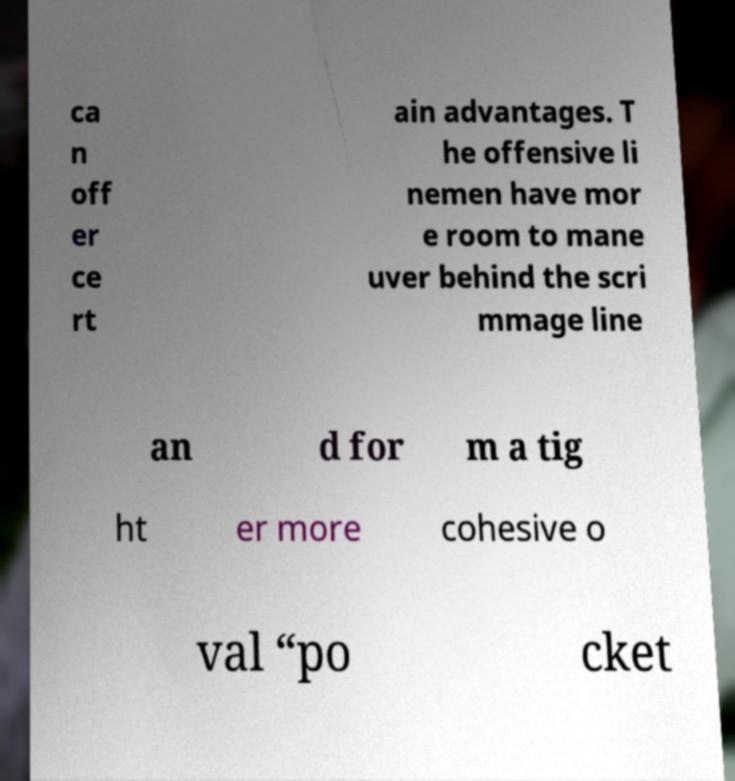Can you accurately transcribe the text from the provided image for me? ca n off er ce rt ain advantages. T he offensive li nemen have mor e room to mane uver behind the scri mmage line an d for m a tig ht er more cohesive o val “po cket 